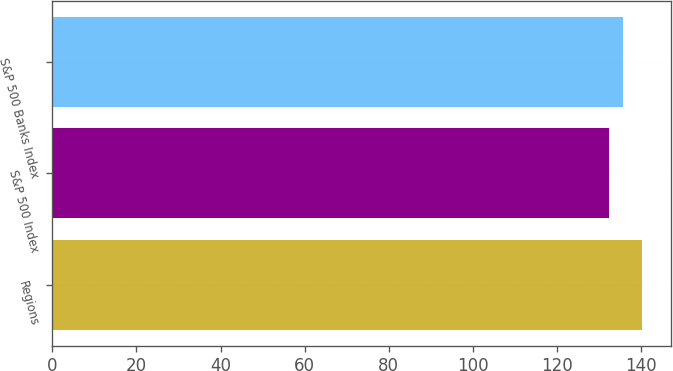Convert chart. <chart><loc_0><loc_0><loc_500><loc_500><bar_chart><fcel>Regions<fcel>S&P 500 Index<fcel>S&P 500 Banks Index<nl><fcel>140.22<fcel>132.37<fcel>135.72<nl></chart> 